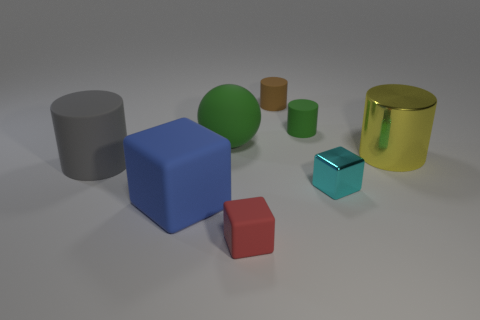The small matte object that is the same color as the rubber sphere is what shape?
Provide a short and direct response. Cylinder. How many brown cylinders are in front of the metal thing that is in front of the yellow metal cylinder?
Ensure brevity in your answer.  0. Are there any other brown objects of the same shape as the large metallic object?
Provide a succinct answer. Yes. Is the size of the shiny thing left of the big yellow thing the same as the rubber cylinder that is in front of the yellow cylinder?
Ensure brevity in your answer.  No. The small rubber thing that is in front of the green rubber thing on the right side of the tiny red rubber block is what shape?
Provide a short and direct response. Cube. How many cyan objects have the same size as the brown cylinder?
Ensure brevity in your answer.  1. Is there a small cyan metal block?
Your response must be concise. Yes. Are there any other things that have the same color as the large shiny cylinder?
Give a very brief answer. No. There is a tiny brown object that is the same material as the gray object; what is its shape?
Provide a short and direct response. Cylinder. What is the color of the rubber cylinder in front of the big rubber object behind the large cylinder to the left of the shiny cylinder?
Your answer should be compact. Gray. 